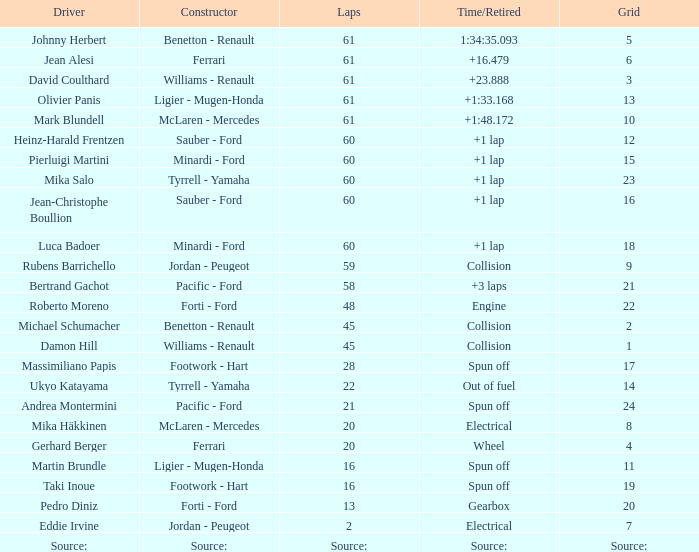What's the time/retired for constructor source:? Source:. 